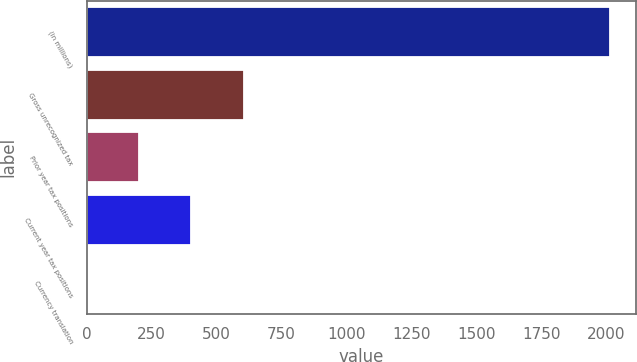Convert chart. <chart><loc_0><loc_0><loc_500><loc_500><bar_chart><fcel>(in millions)<fcel>Gross unrecognized tax<fcel>Prior year tax positions<fcel>Current year tax positions<fcel>Currency translation<nl><fcel>2013<fcel>603.97<fcel>201.39<fcel>402.68<fcel>0.1<nl></chart> 